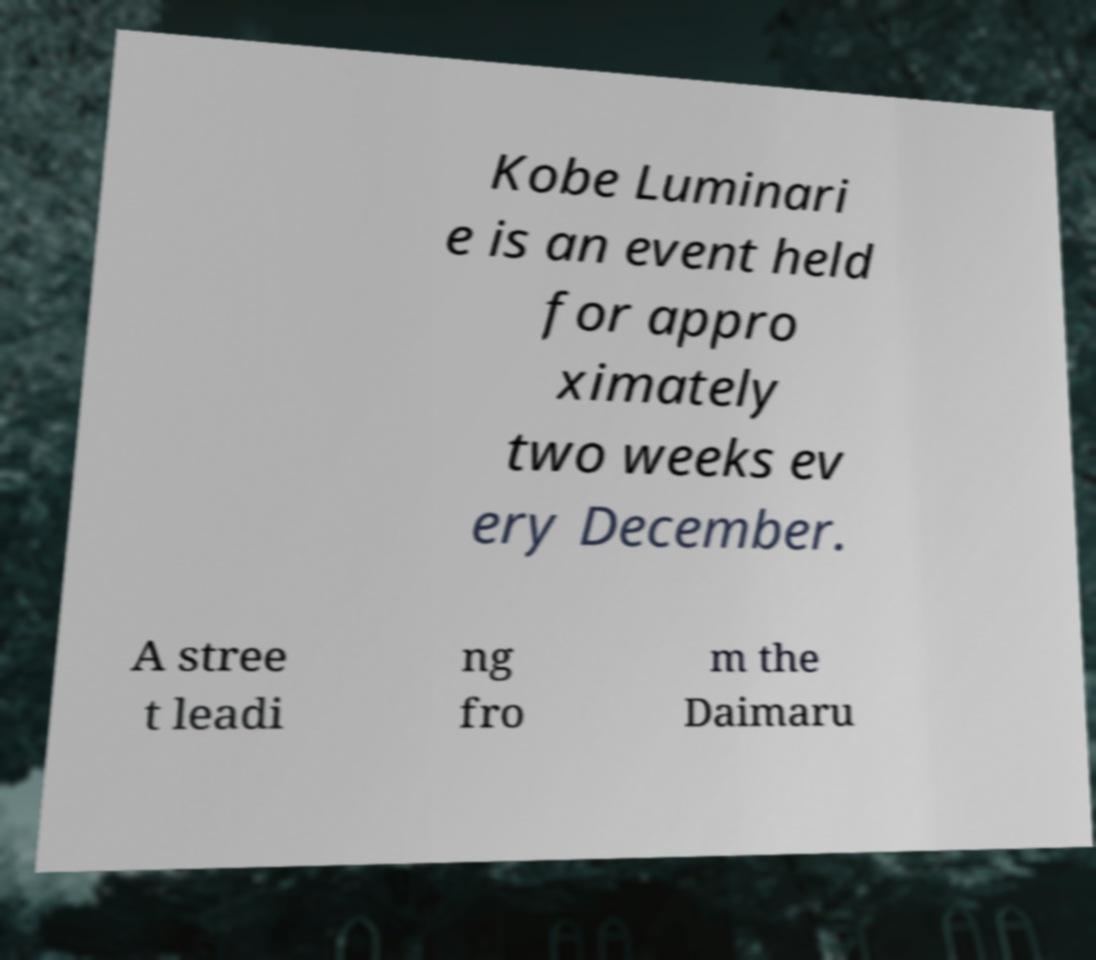Please read and relay the text visible in this image. What does it say? Kobe Luminari e is an event held for appro ximately two weeks ev ery December. A stree t leadi ng fro m the Daimaru 